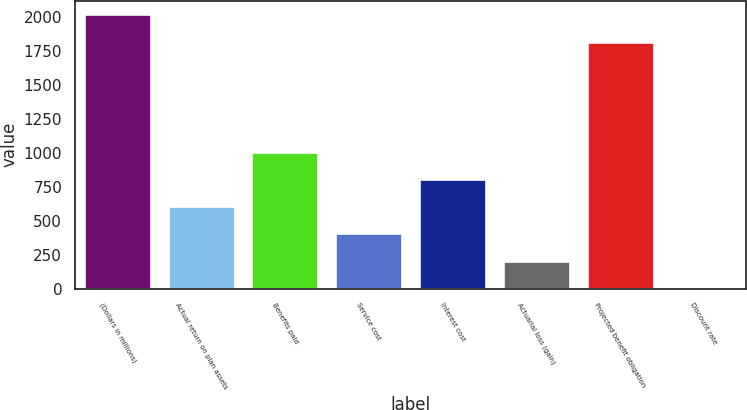Convert chart to OTSL. <chart><loc_0><loc_0><loc_500><loc_500><bar_chart><fcel>(Dollars in millions)<fcel>Actual return on plan assets<fcel>Benefits paid<fcel>Service cost<fcel>Interest cost<fcel>Actuarial loss (gain)<fcel>Projected benefit obligation<fcel>Discount rate<nl><fcel>2020.65<fcel>606.74<fcel>1007.4<fcel>406.41<fcel>807.07<fcel>206.08<fcel>1820.33<fcel>5.75<nl></chart> 